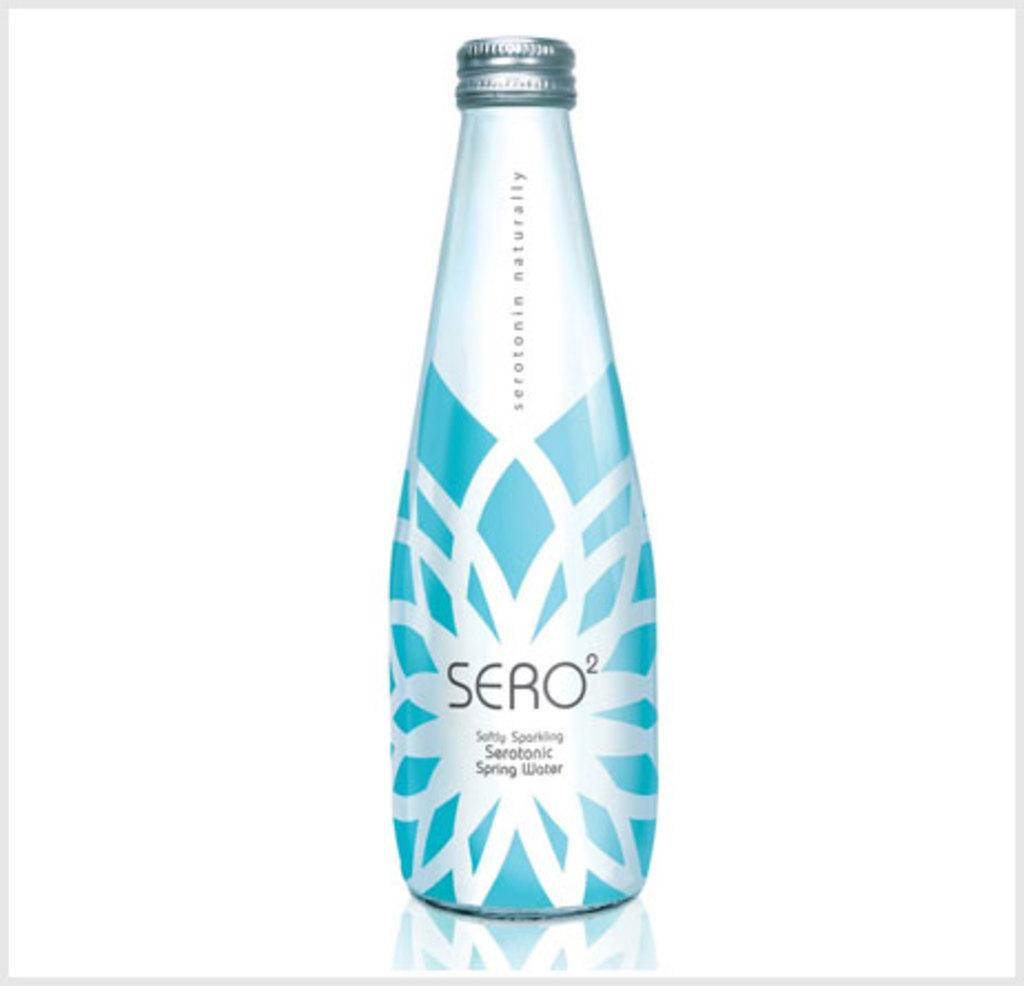<image>
Present a compact description of the photo's key features. A bottle of Seratonic Spring Water called Sero2 